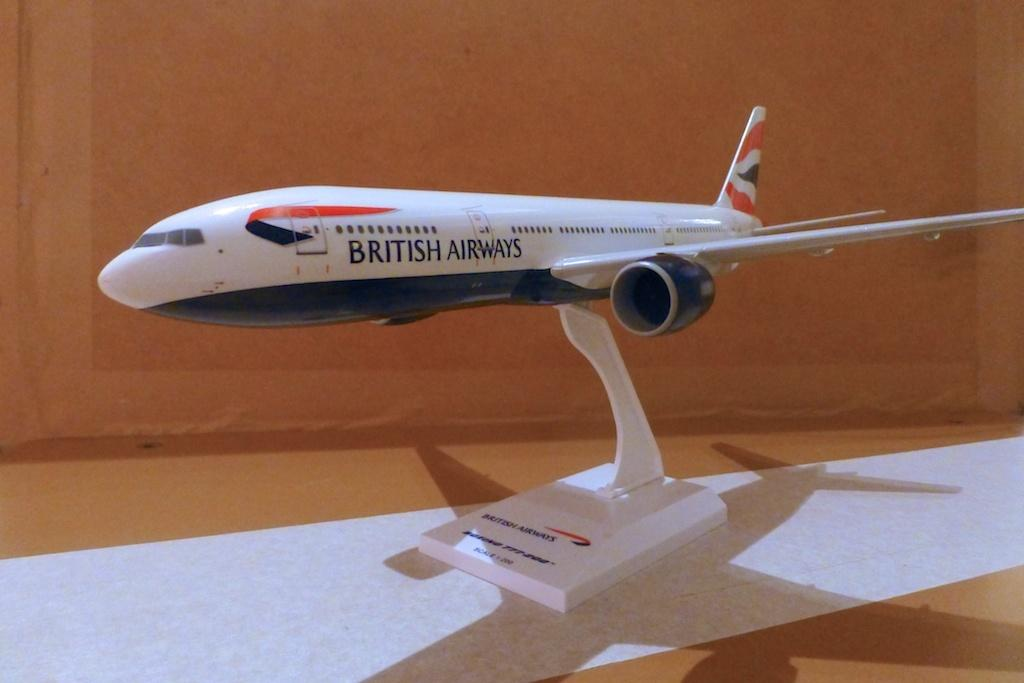Provide a one-sentence caption for the provided image. A white model plane, with the text British Airways, sits on a desk. 